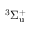Convert formula to latex. <formula><loc_0><loc_0><loc_500><loc_500>^ { 3 } \Sigma _ { u } ^ { + }</formula> 